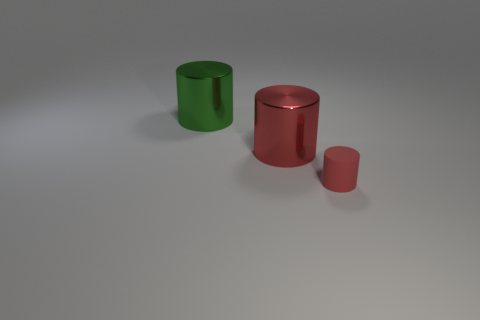What number of large cylinders are in front of the red shiny thing right of the object left of the large red cylinder?
Your answer should be compact. 0. There is a large object behind the large red shiny object; is its shape the same as the small red thing?
Give a very brief answer. Yes. How many things are either small things or green metallic cylinders behind the tiny red object?
Provide a succinct answer. 2. Is the number of things that are behind the green metallic cylinder greater than the number of large red cylinders?
Make the answer very short. No. Is the number of red cylinders in front of the red matte object the same as the number of tiny red objects right of the large green metal cylinder?
Give a very brief answer. No. Are there any large metal things that are right of the red thing that is left of the small red object?
Your response must be concise. No. What is the shape of the small red rubber thing?
Offer a terse response. Cylinder. There is another cylinder that is the same color as the tiny cylinder; what is its size?
Ensure brevity in your answer.  Large. What size is the object behind the red cylinder that is behind the tiny rubber object?
Give a very brief answer. Large. What size is the object behind the red shiny thing?
Your answer should be very brief. Large. 